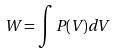<formula> <loc_0><loc_0><loc_500><loc_500>W = \int P ( V ) d V</formula> 